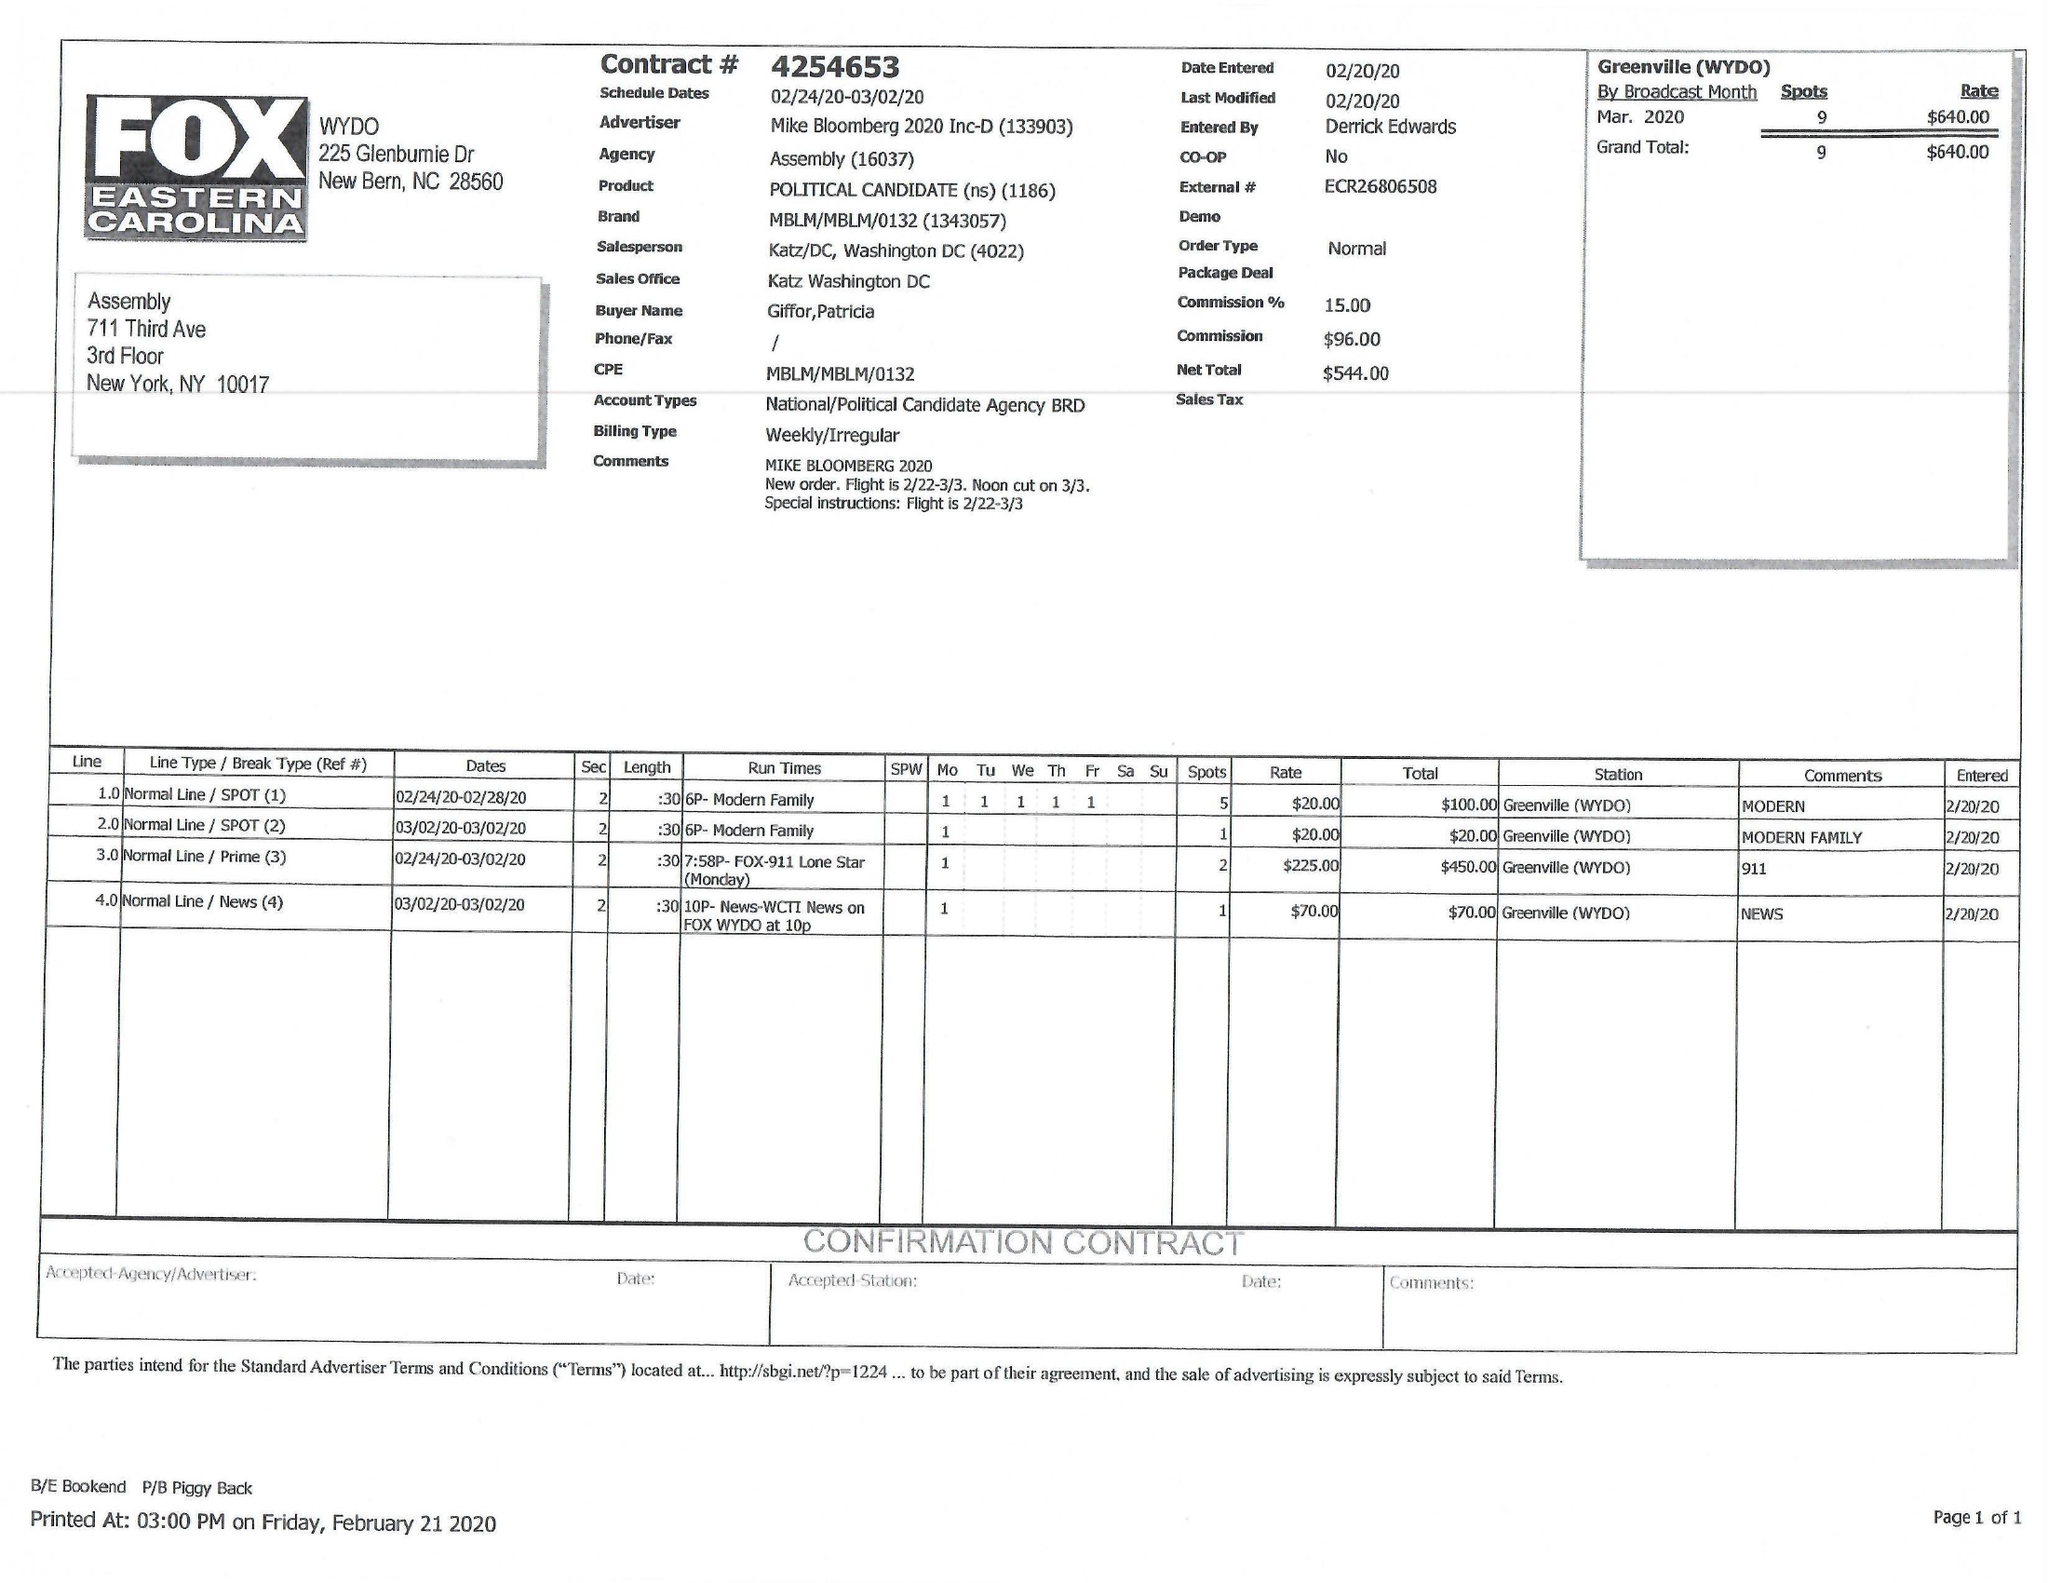What is the value for the flight_from?
Answer the question using a single word or phrase. 02/24/20 